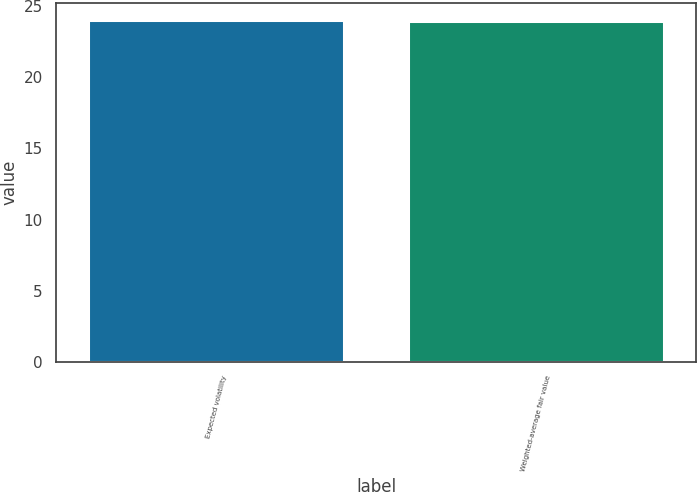Convert chart to OTSL. <chart><loc_0><loc_0><loc_500><loc_500><bar_chart><fcel>Expected volatility<fcel>Weighted-average fair value<nl><fcel>24<fcel>23.96<nl></chart> 